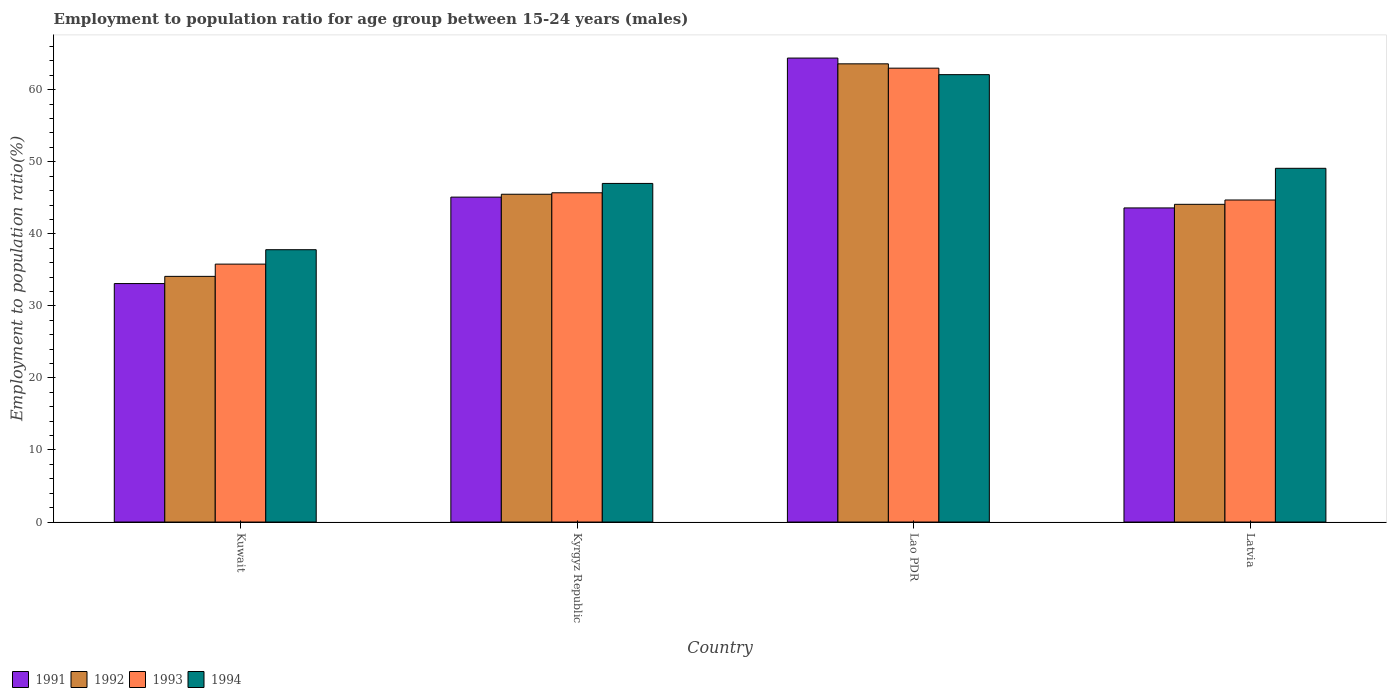How many different coloured bars are there?
Give a very brief answer. 4. Are the number of bars on each tick of the X-axis equal?
Offer a terse response. Yes. How many bars are there on the 2nd tick from the left?
Provide a succinct answer. 4. What is the label of the 2nd group of bars from the left?
Give a very brief answer. Kyrgyz Republic. What is the employment to population ratio in 1993 in Latvia?
Keep it short and to the point. 44.7. Across all countries, what is the maximum employment to population ratio in 1991?
Your response must be concise. 64.4. Across all countries, what is the minimum employment to population ratio in 1993?
Keep it short and to the point. 35.8. In which country was the employment to population ratio in 1994 maximum?
Offer a very short reply. Lao PDR. In which country was the employment to population ratio in 1993 minimum?
Offer a terse response. Kuwait. What is the total employment to population ratio in 1991 in the graph?
Make the answer very short. 186.2. What is the difference between the employment to population ratio in 1994 in Kyrgyz Republic and that in Latvia?
Your response must be concise. -2.1. What is the difference between the employment to population ratio in 1991 in Kyrgyz Republic and the employment to population ratio in 1994 in Latvia?
Offer a very short reply. -4. What is the average employment to population ratio in 1993 per country?
Make the answer very short. 47.3. What is the difference between the employment to population ratio of/in 1993 and employment to population ratio of/in 1991 in Latvia?
Give a very brief answer. 1.1. What is the ratio of the employment to population ratio in 1994 in Kyrgyz Republic to that in Latvia?
Provide a short and direct response. 0.96. What is the difference between the highest and the lowest employment to population ratio in 1992?
Give a very brief answer. 29.5. Is the sum of the employment to population ratio in 1993 in Kyrgyz Republic and Latvia greater than the maximum employment to population ratio in 1991 across all countries?
Offer a terse response. Yes. Is it the case that in every country, the sum of the employment to population ratio in 1994 and employment to population ratio in 1993 is greater than the employment to population ratio in 1992?
Make the answer very short. Yes. How many bars are there?
Ensure brevity in your answer.  16. Are all the bars in the graph horizontal?
Your answer should be compact. No. What is the difference between two consecutive major ticks on the Y-axis?
Your answer should be compact. 10. Where does the legend appear in the graph?
Ensure brevity in your answer.  Bottom left. How many legend labels are there?
Provide a short and direct response. 4. How are the legend labels stacked?
Your response must be concise. Horizontal. What is the title of the graph?
Your response must be concise. Employment to population ratio for age group between 15-24 years (males). Does "2000" appear as one of the legend labels in the graph?
Make the answer very short. No. What is the label or title of the Y-axis?
Your response must be concise. Employment to population ratio(%). What is the Employment to population ratio(%) in 1991 in Kuwait?
Your answer should be very brief. 33.1. What is the Employment to population ratio(%) of 1992 in Kuwait?
Give a very brief answer. 34.1. What is the Employment to population ratio(%) in 1993 in Kuwait?
Give a very brief answer. 35.8. What is the Employment to population ratio(%) of 1994 in Kuwait?
Provide a short and direct response. 37.8. What is the Employment to population ratio(%) of 1991 in Kyrgyz Republic?
Offer a very short reply. 45.1. What is the Employment to population ratio(%) in 1992 in Kyrgyz Republic?
Make the answer very short. 45.5. What is the Employment to population ratio(%) of 1993 in Kyrgyz Republic?
Offer a terse response. 45.7. What is the Employment to population ratio(%) in 1991 in Lao PDR?
Your answer should be compact. 64.4. What is the Employment to population ratio(%) in 1992 in Lao PDR?
Offer a terse response. 63.6. What is the Employment to population ratio(%) of 1994 in Lao PDR?
Offer a terse response. 62.1. What is the Employment to population ratio(%) in 1991 in Latvia?
Your answer should be very brief. 43.6. What is the Employment to population ratio(%) of 1992 in Latvia?
Provide a succinct answer. 44.1. What is the Employment to population ratio(%) in 1993 in Latvia?
Provide a short and direct response. 44.7. What is the Employment to population ratio(%) of 1994 in Latvia?
Your answer should be compact. 49.1. Across all countries, what is the maximum Employment to population ratio(%) of 1991?
Your answer should be very brief. 64.4. Across all countries, what is the maximum Employment to population ratio(%) of 1992?
Make the answer very short. 63.6. Across all countries, what is the maximum Employment to population ratio(%) of 1993?
Provide a short and direct response. 63. Across all countries, what is the maximum Employment to population ratio(%) of 1994?
Make the answer very short. 62.1. Across all countries, what is the minimum Employment to population ratio(%) of 1991?
Keep it short and to the point. 33.1. Across all countries, what is the minimum Employment to population ratio(%) in 1992?
Make the answer very short. 34.1. Across all countries, what is the minimum Employment to population ratio(%) of 1993?
Offer a very short reply. 35.8. Across all countries, what is the minimum Employment to population ratio(%) in 1994?
Your response must be concise. 37.8. What is the total Employment to population ratio(%) in 1991 in the graph?
Offer a terse response. 186.2. What is the total Employment to population ratio(%) of 1992 in the graph?
Keep it short and to the point. 187.3. What is the total Employment to population ratio(%) in 1993 in the graph?
Provide a succinct answer. 189.2. What is the total Employment to population ratio(%) in 1994 in the graph?
Ensure brevity in your answer.  196. What is the difference between the Employment to population ratio(%) in 1991 in Kuwait and that in Kyrgyz Republic?
Give a very brief answer. -12. What is the difference between the Employment to population ratio(%) of 1992 in Kuwait and that in Kyrgyz Republic?
Offer a very short reply. -11.4. What is the difference between the Employment to population ratio(%) in 1994 in Kuwait and that in Kyrgyz Republic?
Your answer should be very brief. -9.2. What is the difference between the Employment to population ratio(%) of 1991 in Kuwait and that in Lao PDR?
Make the answer very short. -31.3. What is the difference between the Employment to population ratio(%) in 1992 in Kuwait and that in Lao PDR?
Offer a very short reply. -29.5. What is the difference between the Employment to population ratio(%) of 1993 in Kuwait and that in Lao PDR?
Offer a terse response. -27.2. What is the difference between the Employment to population ratio(%) of 1994 in Kuwait and that in Lao PDR?
Offer a very short reply. -24.3. What is the difference between the Employment to population ratio(%) of 1992 in Kuwait and that in Latvia?
Offer a terse response. -10. What is the difference between the Employment to population ratio(%) in 1993 in Kuwait and that in Latvia?
Give a very brief answer. -8.9. What is the difference between the Employment to population ratio(%) in 1991 in Kyrgyz Republic and that in Lao PDR?
Keep it short and to the point. -19.3. What is the difference between the Employment to population ratio(%) of 1992 in Kyrgyz Republic and that in Lao PDR?
Keep it short and to the point. -18.1. What is the difference between the Employment to population ratio(%) in 1993 in Kyrgyz Republic and that in Lao PDR?
Your response must be concise. -17.3. What is the difference between the Employment to population ratio(%) of 1994 in Kyrgyz Republic and that in Lao PDR?
Your answer should be compact. -15.1. What is the difference between the Employment to population ratio(%) in 1992 in Kyrgyz Republic and that in Latvia?
Keep it short and to the point. 1.4. What is the difference between the Employment to population ratio(%) in 1991 in Lao PDR and that in Latvia?
Offer a terse response. 20.8. What is the difference between the Employment to population ratio(%) of 1991 in Kuwait and the Employment to population ratio(%) of 1992 in Kyrgyz Republic?
Keep it short and to the point. -12.4. What is the difference between the Employment to population ratio(%) of 1991 in Kuwait and the Employment to population ratio(%) of 1993 in Kyrgyz Republic?
Your response must be concise. -12.6. What is the difference between the Employment to population ratio(%) of 1991 in Kuwait and the Employment to population ratio(%) of 1994 in Kyrgyz Republic?
Your response must be concise. -13.9. What is the difference between the Employment to population ratio(%) of 1992 in Kuwait and the Employment to population ratio(%) of 1994 in Kyrgyz Republic?
Keep it short and to the point. -12.9. What is the difference between the Employment to population ratio(%) of 1993 in Kuwait and the Employment to population ratio(%) of 1994 in Kyrgyz Republic?
Provide a short and direct response. -11.2. What is the difference between the Employment to population ratio(%) in 1991 in Kuwait and the Employment to population ratio(%) in 1992 in Lao PDR?
Provide a short and direct response. -30.5. What is the difference between the Employment to population ratio(%) of 1991 in Kuwait and the Employment to population ratio(%) of 1993 in Lao PDR?
Your answer should be very brief. -29.9. What is the difference between the Employment to population ratio(%) of 1991 in Kuwait and the Employment to population ratio(%) of 1994 in Lao PDR?
Your answer should be very brief. -29. What is the difference between the Employment to population ratio(%) of 1992 in Kuwait and the Employment to population ratio(%) of 1993 in Lao PDR?
Your answer should be compact. -28.9. What is the difference between the Employment to population ratio(%) of 1992 in Kuwait and the Employment to population ratio(%) of 1994 in Lao PDR?
Provide a succinct answer. -28. What is the difference between the Employment to population ratio(%) of 1993 in Kuwait and the Employment to population ratio(%) of 1994 in Lao PDR?
Provide a short and direct response. -26.3. What is the difference between the Employment to population ratio(%) in 1991 in Kuwait and the Employment to population ratio(%) in 1992 in Latvia?
Make the answer very short. -11. What is the difference between the Employment to population ratio(%) of 1992 in Kuwait and the Employment to population ratio(%) of 1993 in Latvia?
Make the answer very short. -10.6. What is the difference between the Employment to population ratio(%) in 1992 in Kuwait and the Employment to population ratio(%) in 1994 in Latvia?
Give a very brief answer. -15. What is the difference between the Employment to population ratio(%) of 1993 in Kuwait and the Employment to population ratio(%) of 1994 in Latvia?
Provide a short and direct response. -13.3. What is the difference between the Employment to population ratio(%) in 1991 in Kyrgyz Republic and the Employment to population ratio(%) in 1992 in Lao PDR?
Provide a succinct answer. -18.5. What is the difference between the Employment to population ratio(%) of 1991 in Kyrgyz Republic and the Employment to population ratio(%) of 1993 in Lao PDR?
Offer a very short reply. -17.9. What is the difference between the Employment to population ratio(%) in 1991 in Kyrgyz Republic and the Employment to population ratio(%) in 1994 in Lao PDR?
Offer a very short reply. -17. What is the difference between the Employment to population ratio(%) of 1992 in Kyrgyz Republic and the Employment to population ratio(%) of 1993 in Lao PDR?
Offer a very short reply. -17.5. What is the difference between the Employment to population ratio(%) of 1992 in Kyrgyz Republic and the Employment to population ratio(%) of 1994 in Lao PDR?
Provide a succinct answer. -16.6. What is the difference between the Employment to population ratio(%) of 1993 in Kyrgyz Republic and the Employment to population ratio(%) of 1994 in Lao PDR?
Give a very brief answer. -16.4. What is the difference between the Employment to population ratio(%) of 1991 in Kyrgyz Republic and the Employment to population ratio(%) of 1992 in Latvia?
Provide a succinct answer. 1. What is the difference between the Employment to population ratio(%) in 1991 in Kyrgyz Republic and the Employment to population ratio(%) in 1993 in Latvia?
Make the answer very short. 0.4. What is the difference between the Employment to population ratio(%) of 1991 in Lao PDR and the Employment to population ratio(%) of 1992 in Latvia?
Make the answer very short. 20.3. What is the difference between the Employment to population ratio(%) of 1991 in Lao PDR and the Employment to population ratio(%) of 1994 in Latvia?
Offer a very short reply. 15.3. What is the difference between the Employment to population ratio(%) in 1993 in Lao PDR and the Employment to population ratio(%) in 1994 in Latvia?
Ensure brevity in your answer.  13.9. What is the average Employment to population ratio(%) in 1991 per country?
Your response must be concise. 46.55. What is the average Employment to population ratio(%) of 1992 per country?
Keep it short and to the point. 46.83. What is the average Employment to population ratio(%) of 1993 per country?
Your answer should be compact. 47.3. What is the average Employment to population ratio(%) in 1994 per country?
Make the answer very short. 49. What is the difference between the Employment to population ratio(%) of 1991 and Employment to population ratio(%) of 1994 in Kuwait?
Offer a terse response. -4.7. What is the difference between the Employment to population ratio(%) in 1992 and Employment to population ratio(%) in 1993 in Kuwait?
Provide a succinct answer. -1.7. What is the difference between the Employment to population ratio(%) in 1993 and Employment to population ratio(%) in 1994 in Kuwait?
Your answer should be compact. -2. What is the difference between the Employment to population ratio(%) of 1991 and Employment to population ratio(%) of 1993 in Lao PDR?
Keep it short and to the point. 1.4. What is the difference between the Employment to population ratio(%) in 1991 and Employment to population ratio(%) in 1994 in Lao PDR?
Make the answer very short. 2.3. What is the difference between the Employment to population ratio(%) in 1991 and Employment to population ratio(%) in 1992 in Latvia?
Provide a succinct answer. -0.5. What is the difference between the Employment to population ratio(%) of 1991 and Employment to population ratio(%) of 1994 in Latvia?
Keep it short and to the point. -5.5. What is the difference between the Employment to population ratio(%) in 1992 and Employment to population ratio(%) in 1993 in Latvia?
Offer a terse response. -0.6. What is the difference between the Employment to population ratio(%) in 1992 and Employment to population ratio(%) in 1994 in Latvia?
Ensure brevity in your answer.  -5. What is the difference between the Employment to population ratio(%) of 1993 and Employment to population ratio(%) of 1994 in Latvia?
Offer a terse response. -4.4. What is the ratio of the Employment to population ratio(%) in 1991 in Kuwait to that in Kyrgyz Republic?
Provide a succinct answer. 0.73. What is the ratio of the Employment to population ratio(%) of 1992 in Kuwait to that in Kyrgyz Republic?
Provide a short and direct response. 0.75. What is the ratio of the Employment to population ratio(%) of 1993 in Kuwait to that in Kyrgyz Republic?
Provide a succinct answer. 0.78. What is the ratio of the Employment to population ratio(%) in 1994 in Kuwait to that in Kyrgyz Republic?
Your response must be concise. 0.8. What is the ratio of the Employment to population ratio(%) in 1991 in Kuwait to that in Lao PDR?
Your answer should be compact. 0.51. What is the ratio of the Employment to population ratio(%) in 1992 in Kuwait to that in Lao PDR?
Provide a succinct answer. 0.54. What is the ratio of the Employment to population ratio(%) of 1993 in Kuwait to that in Lao PDR?
Make the answer very short. 0.57. What is the ratio of the Employment to population ratio(%) of 1994 in Kuwait to that in Lao PDR?
Ensure brevity in your answer.  0.61. What is the ratio of the Employment to population ratio(%) of 1991 in Kuwait to that in Latvia?
Make the answer very short. 0.76. What is the ratio of the Employment to population ratio(%) of 1992 in Kuwait to that in Latvia?
Ensure brevity in your answer.  0.77. What is the ratio of the Employment to population ratio(%) in 1993 in Kuwait to that in Latvia?
Keep it short and to the point. 0.8. What is the ratio of the Employment to population ratio(%) in 1994 in Kuwait to that in Latvia?
Provide a short and direct response. 0.77. What is the ratio of the Employment to population ratio(%) of 1991 in Kyrgyz Republic to that in Lao PDR?
Make the answer very short. 0.7. What is the ratio of the Employment to population ratio(%) of 1992 in Kyrgyz Republic to that in Lao PDR?
Keep it short and to the point. 0.72. What is the ratio of the Employment to population ratio(%) of 1993 in Kyrgyz Republic to that in Lao PDR?
Offer a very short reply. 0.73. What is the ratio of the Employment to population ratio(%) of 1994 in Kyrgyz Republic to that in Lao PDR?
Give a very brief answer. 0.76. What is the ratio of the Employment to population ratio(%) of 1991 in Kyrgyz Republic to that in Latvia?
Your answer should be compact. 1.03. What is the ratio of the Employment to population ratio(%) of 1992 in Kyrgyz Republic to that in Latvia?
Ensure brevity in your answer.  1.03. What is the ratio of the Employment to population ratio(%) in 1993 in Kyrgyz Republic to that in Latvia?
Your answer should be compact. 1.02. What is the ratio of the Employment to population ratio(%) in 1994 in Kyrgyz Republic to that in Latvia?
Offer a very short reply. 0.96. What is the ratio of the Employment to population ratio(%) of 1991 in Lao PDR to that in Latvia?
Provide a succinct answer. 1.48. What is the ratio of the Employment to population ratio(%) of 1992 in Lao PDR to that in Latvia?
Your response must be concise. 1.44. What is the ratio of the Employment to population ratio(%) in 1993 in Lao PDR to that in Latvia?
Offer a terse response. 1.41. What is the ratio of the Employment to population ratio(%) of 1994 in Lao PDR to that in Latvia?
Offer a terse response. 1.26. What is the difference between the highest and the second highest Employment to population ratio(%) in 1991?
Keep it short and to the point. 19.3. What is the difference between the highest and the second highest Employment to population ratio(%) in 1992?
Your response must be concise. 18.1. What is the difference between the highest and the second highest Employment to population ratio(%) in 1993?
Provide a short and direct response. 17.3. What is the difference between the highest and the lowest Employment to population ratio(%) in 1991?
Keep it short and to the point. 31.3. What is the difference between the highest and the lowest Employment to population ratio(%) of 1992?
Ensure brevity in your answer.  29.5. What is the difference between the highest and the lowest Employment to population ratio(%) in 1993?
Provide a succinct answer. 27.2. What is the difference between the highest and the lowest Employment to population ratio(%) of 1994?
Your answer should be compact. 24.3. 